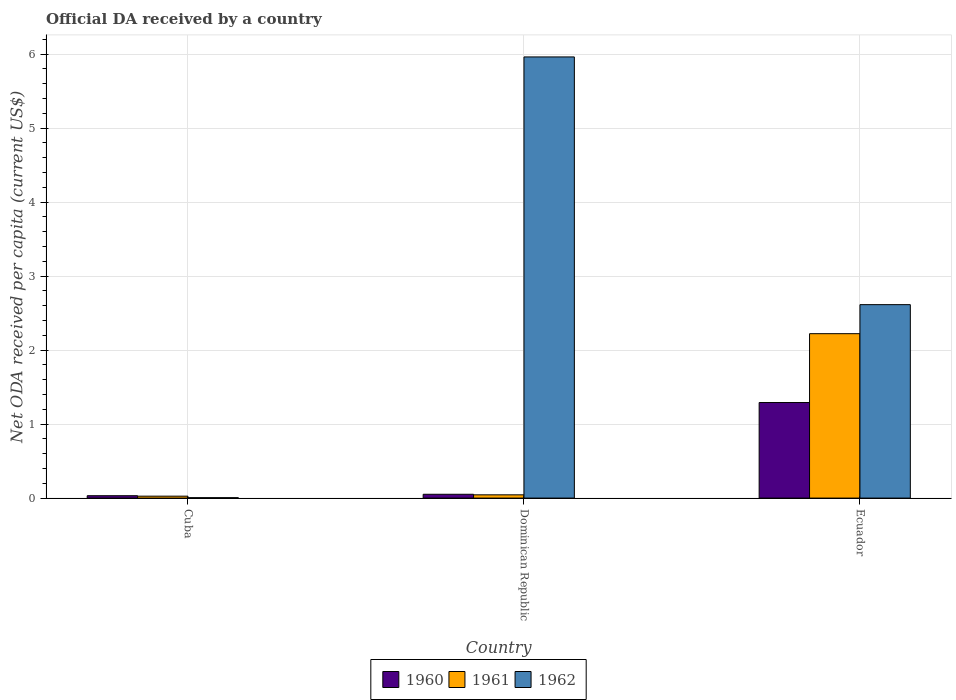How many groups of bars are there?
Your answer should be compact. 3. Are the number of bars per tick equal to the number of legend labels?
Provide a succinct answer. Yes. Are the number of bars on each tick of the X-axis equal?
Offer a very short reply. Yes. How many bars are there on the 1st tick from the left?
Offer a very short reply. 3. What is the label of the 3rd group of bars from the left?
Your answer should be very brief. Ecuador. What is the ODA received in in 1960 in Dominican Republic?
Your response must be concise. 0.05. Across all countries, what is the maximum ODA received in in 1960?
Your response must be concise. 1.29. Across all countries, what is the minimum ODA received in in 1961?
Your answer should be compact. 0.03. In which country was the ODA received in in 1960 maximum?
Your answer should be very brief. Ecuador. In which country was the ODA received in in 1960 minimum?
Offer a very short reply. Cuba. What is the total ODA received in in 1961 in the graph?
Offer a terse response. 2.29. What is the difference between the ODA received in in 1960 in Cuba and that in Ecuador?
Your answer should be very brief. -1.26. What is the difference between the ODA received in in 1960 in Ecuador and the ODA received in in 1962 in Cuba?
Provide a succinct answer. 1.29. What is the average ODA received in in 1962 per country?
Provide a short and direct response. 2.86. What is the difference between the ODA received in of/in 1961 and ODA received in of/in 1962 in Dominican Republic?
Your answer should be very brief. -5.92. In how many countries, is the ODA received in in 1960 greater than 0.6000000000000001 US$?
Your answer should be very brief. 1. What is the ratio of the ODA received in in 1960 in Cuba to that in Ecuador?
Offer a terse response. 0.02. Is the difference between the ODA received in in 1961 in Cuba and Ecuador greater than the difference between the ODA received in in 1962 in Cuba and Ecuador?
Your answer should be compact. Yes. What is the difference between the highest and the second highest ODA received in in 1960?
Provide a succinct answer. -1.24. What is the difference between the highest and the lowest ODA received in in 1962?
Your response must be concise. 5.96. Is the sum of the ODA received in in 1961 in Cuba and Dominican Republic greater than the maximum ODA received in in 1960 across all countries?
Offer a very short reply. No. What does the 1st bar from the left in Ecuador represents?
Ensure brevity in your answer.  1960. Is it the case that in every country, the sum of the ODA received in in 1961 and ODA received in in 1962 is greater than the ODA received in in 1960?
Ensure brevity in your answer.  No. Are all the bars in the graph horizontal?
Offer a very short reply. No. How many countries are there in the graph?
Provide a succinct answer. 3. What is the difference between two consecutive major ticks on the Y-axis?
Your answer should be very brief. 1. Where does the legend appear in the graph?
Ensure brevity in your answer.  Bottom center. How many legend labels are there?
Give a very brief answer. 3. What is the title of the graph?
Provide a succinct answer. Official DA received by a country. What is the label or title of the Y-axis?
Give a very brief answer. Net ODA received per capita (current US$). What is the Net ODA received per capita (current US$) in 1960 in Cuba?
Provide a succinct answer. 0.03. What is the Net ODA received per capita (current US$) in 1961 in Cuba?
Provide a short and direct response. 0.03. What is the Net ODA received per capita (current US$) of 1962 in Cuba?
Offer a terse response. 0.01. What is the Net ODA received per capita (current US$) in 1960 in Dominican Republic?
Keep it short and to the point. 0.05. What is the Net ODA received per capita (current US$) in 1961 in Dominican Republic?
Ensure brevity in your answer.  0.04. What is the Net ODA received per capita (current US$) of 1962 in Dominican Republic?
Your answer should be very brief. 5.96. What is the Net ODA received per capita (current US$) in 1960 in Ecuador?
Provide a succinct answer. 1.29. What is the Net ODA received per capita (current US$) in 1961 in Ecuador?
Offer a terse response. 2.22. What is the Net ODA received per capita (current US$) in 1962 in Ecuador?
Keep it short and to the point. 2.61. Across all countries, what is the maximum Net ODA received per capita (current US$) of 1960?
Provide a succinct answer. 1.29. Across all countries, what is the maximum Net ODA received per capita (current US$) in 1961?
Make the answer very short. 2.22. Across all countries, what is the maximum Net ODA received per capita (current US$) of 1962?
Provide a short and direct response. 5.96. Across all countries, what is the minimum Net ODA received per capita (current US$) of 1960?
Ensure brevity in your answer.  0.03. Across all countries, what is the minimum Net ODA received per capita (current US$) in 1961?
Provide a short and direct response. 0.03. Across all countries, what is the minimum Net ODA received per capita (current US$) of 1962?
Make the answer very short. 0.01. What is the total Net ODA received per capita (current US$) in 1960 in the graph?
Provide a succinct answer. 1.38. What is the total Net ODA received per capita (current US$) in 1961 in the graph?
Your answer should be compact. 2.29. What is the total Net ODA received per capita (current US$) of 1962 in the graph?
Your answer should be compact. 8.58. What is the difference between the Net ODA received per capita (current US$) of 1960 in Cuba and that in Dominican Republic?
Provide a succinct answer. -0.02. What is the difference between the Net ODA received per capita (current US$) in 1961 in Cuba and that in Dominican Republic?
Your answer should be very brief. -0.02. What is the difference between the Net ODA received per capita (current US$) in 1962 in Cuba and that in Dominican Republic?
Ensure brevity in your answer.  -5.96. What is the difference between the Net ODA received per capita (current US$) of 1960 in Cuba and that in Ecuador?
Offer a terse response. -1.26. What is the difference between the Net ODA received per capita (current US$) in 1961 in Cuba and that in Ecuador?
Provide a short and direct response. -2.2. What is the difference between the Net ODA received per capita (current US$) of 1962 in Cuba and that in Ecuador?
Ensure brevity in your answer.  -2.61. What is the difference between the Net ODA received per capita (current US$) of 1960 in Dominican Republic and that in Ecuador?
Offer a terse response. -1.24. What is the difference between the Net ODA received per capita (current US$) of 1961 in Dominican Republic and that in Ecuador?
Provide a succinct answer. -2.18. What is the difference between the Net ODA received per capita (current US$) of 1962 in Dominican Republic and that in Ecuador?
Offer a very short reply. 3.35. What is the difference between the Net ODA received per capita (current US$) of 1960 in Cuba and the Net ODA received per capita (current US$) of 1961 in Dominican Republic?
Provide a succinct answer. -0.01. What is the difference between the Net ODA received per capita (current US$) of 1960 in Cuba and the Net ODA received per capita (current US$) of 1962 in Dominican Republic?
Your answer should be very brief. -5.93. What is the difference between the Net ODA received per capita (current US$) in 1961 in Cuba and the Net ODA received per capita (current US$) in 1962 in Dominican Republic?
Provide a short and direct response. -5.93. What is the difference between the Net ODA received per capita (current US$) in 1960 in Cuba and the Net ODA received per capita (current US$) in 1961 in Ecuador?
Provide a short and direct response. -2.19. What is the difference between the Net ODA received per capita (current US$) in 1960 in Cuba and the Net ODA received per capita (current US$) in 1962 in Ecuador?
Your answer should be compact. -2.58. What is the difference between the Net ODA received per capita (current US$) in 1961 in Cuba and the Net ODA received per capita (current US$) in 1962 in Ecuador?
Your answer should be compact. -2.59. What is the difference between the Net ODA received per capita (current US$) of 1960 in Dominican Republic and the Net ODA received per capita (current US$) of 1961 in Ecuador?
Give a very brief answer. -2.17. What is the difference between the Net ODA received per capita (current US$) in 1960 in Dominican Republic and the Net ODA received per capita (current US$) in 1962 in Ecuador?
Provide a short and direct response. -2.56. What is the difference between the Net ODA received per capita (current US$) in 1961 in Dominican Republic and the Net ODA received per capita (current US$) in 1962 in Ecuador?
Your answer should be very brief. -2.57. What is the average Net ODA received per capita (current US$) of 1960 per country?
Give a very brief answer. 0.46. What is the average Net ODA received per capita (current US$) in 1961 per country?
Your answer should be compact. 0.76. What is the average Net ODA received per capita (current US$) in 1962 per country?
Make the answer very short. 2.86. What is the difference between the Net ODA received per capita (current US$) in 1960 and Net ODA received per capita (current US$) in 1961 in Cuba?
Make the answer very short. 0.01. What is the difference between the Net ODA received per capita (current US$) of 1960 and Net ODA received per capita (current US$) of 1962 in Cuba?
Give a very brief answer. 0.03. What is the difference between the Net ODA received per capita (current US$) of 1961 and Net ODA received per capita (current US$) of 1962 in Cuba?
Give a very brief answer. 0.02. What is the difference between the Net ODA received per capita (current US$) in 1960 and Net ODA received per capita (current US$) in 1961 in Dominican Republic?
Your response must be concise. 0.01. What is the difference between the Net ODA received per capita (current US$) in 1960 and Net ODA received per capita (current US$) in 1962 in Dominican Republic?
Keep it short and to the point. -5.91. What is the difference between the Net ODA received per capita (current US$) in 1961 and Net ODA received per capita (current US$) in 1962 in Dominican Republic?
Keep it short and to the point. -5.92. What is the difference between the Net ODA received per capita (current US$) of 1960 and Net ODA received per capita (current US$) of 1961 in Ecuador?
Ensure brevity in your answer.  -0.93. What is the difference between the Net ODA received per capita (current US$) of 1960 and Net ODA received per capita (current US$) of 1962 in Ecuador?
Your answer should be compact. -1.32. What is the difference between the Net ODA received per capita (current US$) in 1961 and Net ODA received per capita (current US$) in 1962 in Ecuador?
Offer a terse response. -0.39. What is the ratio of the Net ODA received per capita (current US$) in 1960 in Cuba to that in Dominican Republic?
Your response must be concise. 0.62. What is the ratio of the Net ODA received per capita (current US$) of 1961 in Cuba to that in Dominican Republic?
Provide a succinct answer. 0.59. What is the ratio of the Net ODA received per capita (current US$) in 1962 in Cuba to that in Dominican Republic?
Offer a terse response. 0. What is the ratio of the Net ODA received per capita (current US$) in 1960 in Cuba to that in Ecuador?
Provide a succinct answer. 0.02. What is the ratio of the Net ODA received per capita (current US$) of 1961 in Cuba to that in Ecuador?
Provide a succinct answer. 0.01. What is the ratio of the Net ODA received per capita (current US$) of 1962 in Cuba to that in Ecuador?
Offer a terse response. 0. What is the ratio of the Net ODA received per capita (current US$) in 1960 in Dominican Republic to that in Ecuador?
Your response must be concise. 0.04. What is the ratio of the Net ODA received per capita (current US$) in 1961 in Dominican Republic to that in Ecuador?
Keep it short and to the point. 0.02. What is the ratio of the Net ODA received per capita (current US$) in 1962 in Dominican Republic to that in Ecuador?
Your answer should be compact. 2.28. What is the difference between the highest and the second highest Net ODA received per capita (current US$) of 1960?
Give a very brief answer. 1.24. What is the difference between the highest and the second highest Net ODA received per capita (current US$) in 1961?
Provide a succinct answer. 2.18. What is the difference between the highest and the second highest Net ODA received per capita (current US$) of 1962?
Give a very brief answer. 3.35. What is the difference between the highest and the lowest Net ODA received per capita (current US$) in 1960?
Offer a very short reply. 1.26. What is the difference between the highest and the lowest Net ODA received per capita (current US$) of 1961?
Offer a very short reply. 2.2. What is the difference between the highest and the lowest Net ODA received per capita (current US$) in 1962?
Offer a terse response. 5.96. 